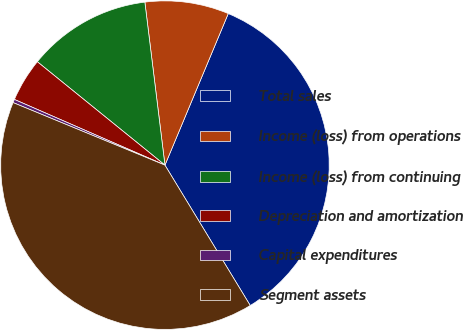Convert chart. <chart><loc_0><loc_0><loc_500><loc_500><pie_chart><fcel>Total sales<fcel>Income (loss) from operations<fcel>Income (loss) from continuing<fcel>Depreciation and amortization<fcel>Capital expenditures<fcel>Segment assets<nl><fcel>35.01%<fcel>8.25%<fcel>12.21%<fcel>4.29%<fcel>0.33%<fcel>39.91%<nl></chart> 